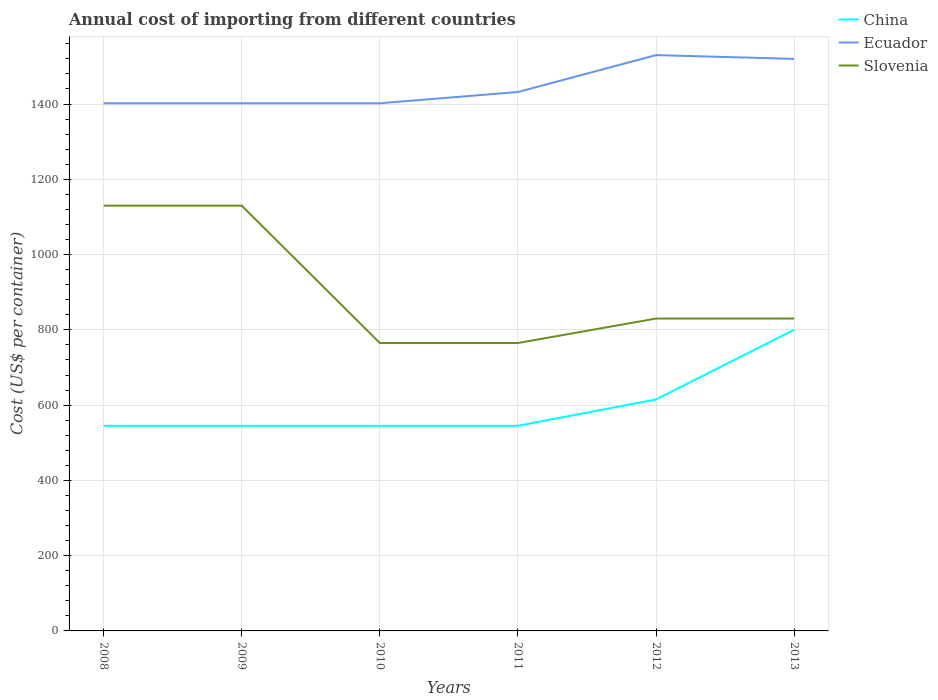How many different coloured lines are there?
Provide a short and direct response. 3. Across all years, what is the maximum total annual cost of importing in China?
Provide a succinct answer. 545. In which year was the total annual cost of importing in China maximum?
Keep it short and to the point. 2008. What is the difference between the highest and the second highest total annual cost of importing in Slovenia?
Ensure brevity in your answer.  365. What is the difference between the highest and the lowest total annual cost of importing in Slovenia?
Your answer should be very brief. 2. Is the total annual cost of importing in Ecuador strictly greater than the total annual cost of importing in China over the years?
Provide a succinct answer. No. How many years are there in the graph?
Offer a terse response. 6. Does the graph contain grids?
Make the answer very short. Yes. How many legend labels are there?
Make the answer very short. 3. What is the title of the graph?
Keep it short and to the point. Annual cost of importing from different countries. What is the label or title of the Y-axis?
Provide a short and direct response. Cost (US$ per container). What is the Cost (US$ per container) of China in 2008?
Your answer should be very brief. 545. What is the Cost (US$ per container) in Ecuador in 2008?
Ensure brevity in your answer.  1402. What is the Cost (US$ per container) of Slovenia in 2008?
Your answer should be very brief. 1130. What is the Cost (US$ per container) of China in 2009?
Ensure brevity in your answer.  545. What is the Cost (US$ per container) in Ecuador in 2009?
Your answer should be very brief. 1402. What is the Cost (US$ per container) of Slovenia in 2009?
Your answer should be very brief. 1130. What is the Cost (US$ per container) in China in 2010?
Ensure brevity in your answer.  545. What is the Cost (US$ per container) of Ecuador in 2010?
Provide a short and direct response. 1402. What is the Cost (US$ per container) of Slovenia in 2010?
Your answer should be very brief. 765. What is the Cost (US$ per container) in China in 2011?
Your answer should be compact. 545. What is the Cost (US$ per container) of Ecuador in 2011?
Ensure brevity in your answer.  1432. What is the Cost (US$ per container) in Slovenia in 2011?
Provide a short and direct response. 765. What is the Cost (US$ per container) of China in 2012?
Offer a very short reply. 615. What is the Cost (US$ per container) of Ecuador in 2012?
Keep it short and to the point. 1530. What is the Cost (US$ per container) in Slovenia in 2012?
Your response must be concise. 830. What is the Cost (US$ per container) of China in 2013?
Your answer should be compact. 800. What is the Cost (US$ per container) of Ecuador in 2013?
Your answer should be very brief. 1520. What is the Cost (US$ per container) of Slovenia in 2013?
Provide a short and direct response. 830. Across all years, what is the maximum Cost (US$ per container) in China?
Your answer should be very brief. 800. Across all years, what is the maximum Cost (US$ per container) in Ecuador?
Your answer should be compact. 1530. Across all years, what is the maximum Cost (US$ per container) of Slovenia?
Your answer should be very brief. 1130. Across all years, what is the minimum Cost (US$ per container) of China?
Offer a terse response. 545. Across all years, what is the minimum Cost (US$ per container) of Ecuador?
Your answer should be very brief. 1402. Across all years, what is the minimum Cost (US$ per container) of Slovenia?
Your answer should be very brief. 765. What is the total Cost (US$ per container) of China in the graph?
Your answer should be compact. 3595. What is the total Cost (US$ per container) of Ecuador in the graph?
Offer a terse response. 8688. What is the total Cost (US$ per container) of Slovenia in the graph?
Ensure brevity in your answer.  5450. What is the difference between the Cost (US$ per container) of China in 2008 and that in 2009?
Provide a succinct answer. 0. What is the difference between the Cost (US$ per container) of Ecuador in 2008 and that in 2009?
Your answer should be very brief. 0. What is the difference between the Cost (US$ per container) in Slovenia in 2008 and that in 2009?
Your answer should be very brief. 0. What is the difference between the Cost (US$ per container) in Slovenia in 2008 and that in 2010?
Offer a terse response. 365. What is the difference between the Cost (US$ per container) in Ecuador in 2008 and that in 2011?
Make the answer very short. -30. What is the difference between the Cost (US$ per container) of Slovenia in 2008 and that in 2011?
Ensure brevity in your answer.  365. What is the difference between the Cost (US$ per container) of China in 2008 and that in 2012?
Give a very brief answer. -70. What is the difference between the Cost (US$ per container) in Ecuador in 2008 and that in 2012?
Offer a terse response. -128. What is the difference between the Cost (US$ per container) in Slovenia in 2008 and that in 2012?
Keep it short and to the point. 300. What is the difference between the Cost (US$ per container) in China in 2008 and that in 2013?
Your response must be concise. -255. What is the difference between the Cost (US$ per container) in Ecuador in 2008 and that in 2013?
Offer a terse response. -118. What is the difference between the Cost (US$ per container) of Slovenia in 2008 and that in 2013?
Keep it short and to the point. 300. What is the difference between the Cost (US$ per container) of Ecuador in 2009 and that in 2010?
Ensure brevity in your answer.  0. What is the difference between the Cost (US$ per container) of Slovenia in 2009 and that in 2010?
Your answer should be compact. 365. What is the difference between the Cost (US$ per container) in Ecuador in 2009 and that in 2011?
Your answer should be very brief. -30. What is the difference between the Cost (US$ per container) of Slovenia in 2009 and that in 2011?
Offer a terse response. 365. What is the difference between the Cost (US$ per container) of China in 2009 and that in 2012?
Your response must be concise. -70. What is the difference between the Cost (US$ per container) of Ecuador in 2009 and that in 2012?
Provide a short and direct response. -128. What is the difference between the Cost (US$ per container) in Slovenia in 2009 and that in 2012?
Offer a terse response. 300. What is the difference between the Cost (US$ per container) of China in 2009 and that in 2013?
Your answer should be very brief. -255. What is the difference between the Cost (US$ per container) in Ecuador in 2009 and that in 2013?
Your answer should be compact. -118. What is the difference between the Cost (US$ per container) of Slovenia in 2009 and that in 2013?
Offer a terse response. 300. What is the difference between the Cost (US$ per container) in China in 2010 and that in 2011?
Provide a succinct answer. 0. What is the difference between the Cost (US$ per container) of Ecuador in 2010 and that in 2011?
Offer a terse response. -30. What is the difference between the Cost (US$ per container) of Slovenia in 2010 and that in 2011?
Your answer should be very brief. 0. What is the difference between the Cost (US$ per container) in China in 2010 and that in 2012?
Your answer should be compact. -70. What is the difference between the Cost (US$ per container) of Ecuador in 2010 and that in 2012?
Your response must be concise. -128. What is the difference between the Cost (US$ per container) of Slovenia in 2010 and that in 2012?
Your response must be concise. -65. What is the difference between the Cost (US$ per container) in China in 2010 and that in 2013?
Keep it short and to the point. -255. What is the difference between the Cost (US$ per container) in Ecuador in 2010 and that in 2013?
Ensure brevity in your answer.  -118. What is the difference between the Cost (US$ per container) in Slovenia in 2010 and that in 2013?
Provide a short and direct response. -65. What is the difference between the Cost (US$ per container) in China in 2011 and that in 2012?
Make the answer very short. -70. What is the difference between the Cost (US$ per container) of Ecuador in 2011 and that in 2012?
Offer a terse response. -98. What is the difference between the Cost (US$ per container) of Slovenia in 2011 and that in 2012?
Your response must be concise. -65. What is the difference between the Cost (US$ per container) of China in 2011 and that in 2013?
Provide a short and direct response. -255. What is the difference between the Cost (US$ per container) of Ecuador in 2011 and that in 2013?
Make the answer very short. -88. What is the difference between the Cost (US$ per container) in Slovenia in 2011 and that in 2013?
Make the answer very short. -65. What is the difference between the Cost (US$ per container) in China in 2012 and that in 2013?
Ensure brevity in your answer.  -185. What is the difference between the Cost (US$ per container) of Ecuador in 2012 and that in 2013?
Keep it short and to the point. 10. What is the difference between the Cost (US$ per container) of China in 2008 and the Cost (US$ per container) of Ecuador in 2009?
Provide a succinct answer. -857. What is the difference between the Cost (US$ per container) in China in 2008 and the Cost (US$ per container) in Slovenia in 2009?
Offer a very short reply. -585. What is the difference between the Cost (US$ per container) in Ecuador in 2008 and the Cost (US$ per container) in Slovenia in 2009?
Provide a short and direct response. 272. What is the difference between the Cost (US$ per container) in China in 2008 and the Cost (US$ per container) in Ecuador in 2010?
Provide a succinct answer. -857. What is the difference between the Cost (US$ per container) in China in 2008 and the Cost (US$ per container) in Slovenia in 2010?
Your answer should be very brief. -220. What is the difference between the Cost (US$ per container) of Ecuador in 2008 and the Cost (US$ per container) of Slovenia in 2010?
Your response must be concise. 637. What is the difference between the Cost (US$ per container) in China in 2008 and the Cost (US$ per container) in Ecuador in 2011?
Make the answer very short. -887. What is the difference between the Cost (US$ per container) in China in 2008 and the Cost (US$ per container) in Slovenia in 2011?
Provide a succinct answer. -220. What is the difference between the Cost (US$ per container) in Ecuador in 2008 and the Cost (US$ per container) in Slovenia in 2011?
Offer a very short reply. 637. What is the difference between the Cost (US$ per container) of China in 2008 and the Cost (US$ per container) of Ecuador in 2012?
Keep it short and to the point. -985. What is the difference between the Cost (US$ per container) of China in 2008 and the Cost (US$ per container) of Slovenia in 2012?
Make the answer very short. -285. What is the difference between the Cost (US$ per container) in Ecuador in 2008 and the Cost (US$ per container) in Slovenia in 2012?
Your answer should be very brief. 572. What is the difference between the Cost (US$ per container) in China in 2008 and the Cost (US$ per container) in Ecuador in 2013?
Provide a succinct answer. -975. What is the difference between the Cost (US$ per container) of China in 2008 and the Cost (US$ per container) of Slovenia in 2013?
Your response must be concise. -285. What is the difference between the Cost (US$ per container) in Ecuador in 2008 and the Cost (US$ per container) in Slovenia in 2013?
Provide a succinct answer. 572. What is the difference between the Cost (US$ per container) of China in 2009 and the Cost (US$ per container) of Ecuador in 2010?
Your response must be concise. -857. What is the difference between the Cost (US$ per container) of China in 2009 and the Cost (US$ per container) of Slovenia in 2010?
Ensure brevity in your answer.  -220. What is the difference between the Cost (US$ per container) of Ecuador in 2009 and the Cost (US$ per container) of Slovenia in 2010?
Offer a terse response. 637. What is the difference between the Cost (US$ per container) in China in 2009 and the Cost (US$ per container) in Ecuador in 2011?
Keep it short and to the point. -887. What is the difference between the Cost (US$ per container) of China in 2009 and the Cost (US$ per container) of Slovenia in 2011?
Ensure brevity in your answer.  -220. What is the difference between the Cost (US$ per container) in Ecuador in 2009 and the Cost (US$ per container) in Slovenia in 2011?
Your response must be concise. 637. What is the difference between the Cost (US$ per container) of China in 2009 and the Cost (US$ per container) of Ecuador in 2012?
Offer a very short reply. -985. What is the difference between the Cost (US$ per container) in China in 2009 and the Cost (US$ per container) in Slovenia in 2012?
Give a very brief answer. -285. What is the difference between the Cost (US$ per container) in Ecuador in 2009 and the Cost (US$ per container) in Slovenia in 2012?
Provide a succinct answer. 572. What is the difference between the Cost (US$ per container) in China in 2009 and the Cost (US$ per container) in Ecuador in 2013?
Your answer should be compact. -975. What is the difference between the Cost (US$ per container) of China in 2009 and the Cost (US$ per container) of Slovenia in 2013?
Keep it short and to the point. -285. What is the difference between the Cost (US$ per container) in Ecuador in 2009 and the Cost (US$ per container) in Slovenia in 2013?
Keep it short and to the point. 572. What is the difference between the Cost (US$ per container) in China in 2010 and the Cost (US$ per container) in Ecuador in 2011?
Your answer should be compact. -887. What is the difference between the Cost (US$ per container) in China in 2010 and the Cost (US$ per container) in Slovenia in 2011?
Offer a terse response. -220. What is the difference between the Cost (US$ per container) of Ecuador in 2010 and the Cost (US$ per container) of Slovenia in 2011?
Provide a short and direct response. 637. What is the difference between the Cost (US$ per container) of China in 2010 and the Cost (US$ per container) of Ecuador in 2012?
Provide a short and direct response. -985. What is the difference between the Cost (US$ per container) of China in 2010 and the Cost (US$ per container) of Slovenia in 2012?
Ensure brevity in your answer.  -285. What is the difference between the Cost (US$ per container) in Ecuador in 2010 and the Cost (US$ per container) in Slovenia in 2012?
Offer a very short reply. 572. What is the difference between the Cost (US$ per container) of China in 2010 and the Cost (US$ per container) of Ecuador in 2013?
Provide a succinct answer. -975. What is the difference between the Cost (US$ per container) in China in 2010 and the Cost (US$ per container) in Slovenia in 2013?
Give a very brief answer. -285. What is the difference between the Cost (US$ per container) in Ecuador in 2010 and the Cost (US$ per container) in Slovenia in 2013?
Offer a very short reply. 572. What is the difference between the Cost (US$ per container) in China in 2011 and the Cost (US$ per container) in Ecuador in 2012?
Make the answer very short. -985. What is the difference between the Cost (US$ per container) in China in 2011 and the Cost (US$ per container) in Slovenia in 2012?
Keep it short and to the point. -285. What is the difference between the Cost (US$ per container) of Ecuador in 2011 and the Cost (US$ per container) of Slovenia in 2012?
Provide a short and direct response. 602. What is the difference between the Cost (US$ per container) of China in 2011 and the Cost (US$ per container) of Ecuador in 2013?
Your answer should be compact. -975. What is the difference between the Cost (US$ per container) in China in 2011 and the Cost (US$ per container) in Slovenia in 2013?
Your answer should be compact. -285. What is the difference between the Cost (US$ per container) of Ecuador in 2011 and the Cost (US$ per container) of Slovenia in 2013?
Give a very brief answer. 602. What is the difference between the Cost (US$ per container) in China in 2012 and the Cost (US$ per container) in Ecuador in 2013?
Offer a very short reply. -905. What is the difference between the Cost (US$ per container) of China in 2012 and the Cost (US$ per container) of Slovenia in 2013?
Provide a succinct answer. -215. What is the difference between the Cost (US$ per container) of Ecuador in 2012 and the Cost (US$ per container) of Slovenia in 2013?
Ensure brevity in your answer.  700. What is the average Cost (US$ per container) in China per year?
Provide a short and direct response. 599.17. What is the average Cost (US$ per container) in Ecuador per year?
Offer a very short reply. 1448. What is the average Cost (US$ per container) in Slovenia per year?
Your response must be concise. 908.33. In the year 2008, what is the difference between the Cost (US$ per container) in China and Cost (US$ per container) in Ecuador?
Your response must be concise. -857. In the year 2008, what is the difference between the Cost (US$ per container) of China and Cost (US$ per container) of Slovenia?
Your response must be concise. -585. In the year 2008, what is the difference between the Cost (US$ per container) in Ecuador and Cost (US$ per container) in Slovenia?
Your answer should be compact. 272. In the year 2009, what is the difference between the Cost (US$ per container) of China and Cost (US$ per container) of Ecuador?
Offer a terse response. -857. In the year 2009, what is the difference between the Cost (US$ per container) in China and Cost (US$ per container) in Slovenia?
Give a very brief answer. -585. In the year 2009, what is the difference between the Cost (US$ per container) in Ecuador and Cost (US$ per container) in Slovenia?
Your answer should be very brief. 272. In the year 2010, what is the difference between the Cost (US$ per container) in China and Cost (US$ per container) in Ecuador?
Ensure brevity in your answer.  -857. In the year 2010, what is the difference between the Cost (US$ per container) in China and Cost (US$ per container) in Slovenia?
Your response must be concise. -220. In the year 2010, what is the difference between the Cost (US$ per container) of Ecuador and Cost (US$ per container) of Slovenia?
Give a very brief answer. 637. In the year 2011, what is the difference between the Cost (US$ per container) in China and Cost (US$ per container) in Ecuador?
Give a very brief answer. -887. In the year 2011, what is the difference between the Cost (US$ per container) of China and Cost (US$ per container) of Slovenia?
Offer a terse response. -220. In the year 2011, what is the difference between the Cost (US$ per container) in Ecuador and Cost (US$ per container) in Slovenia?
Offer a terse response. 667. In the year 2012, what is the difference between the Cost (US$ per container) in China and Cost (US$ per container) in Ecuador?
Ensure brevity in your answer.  -915. In the year 2012, what is the difference between the Cost (US$ per container) in China and Cost (US$ per container) in Slovenia?
Your answer should be compact. -215. In the year 2012, what is the difference between the Cost (US$ per container) in Ecuador and Cost (US$ per container) in Slovenia?
Your answer should be compact. 700. In the year 2013, what is the difference between the Cost (US$ per container) of China and Cost (US$ per container) of Ecuador?
Your answer should be compact. -720. In the year 2013, what is the difference between the Cost (US$ per container) in China and Cost (US$ per container) in Slovenia?
Offer a very short reply. -30. In the year 2013, what is the difference between the Cost (US$ per container) of Ecuador and Cost (US$ per container) of Slovenia?
Offer a terse response. 690. What is the ratio of the Cost (US$ per container) in Slovenia in 2008 to that in 2009?
Provide a short and direct response. 1. What is the ratio of the Cost (US$ per container) of Ecuador in 2008 to that in 2010?
Your answer should be compact. 1. What is the ratio of the Cost (US$ per container) of Slovenia in 2008 to that in 2010?
Provide a short and direct response. 1.48. What is the ratio of the Cost (US$ per container) in Ecuador in 2008 to that in 2011?
Your response must be concise. 0.98. What is the ratio of the Cost (US$ per container) in Slovenia in 2008 to that in 2011?
Ensure brevity in your answer.  1.48. What is the ratio of the Cost (US$ per container) in China in 2008 to that in 2012?
Your answer should be compact. 0.89. What is the ratio of the Cost (US$ per container) of Ecuador in 2008 to that in 2012?
Your answer should be compact. 0.92. What is the ratio of the Cost (US$ per container) in Slovenia in 2008 to that in 2012?
Make the answer very short. 1.36. What is the ratio of the Cost (US$ per container) of China in 2008 to that in 2013?
Your answer should be compact. 0.68. What is the ratio of the Cost (US$ per container) in Ecuador in 2008 to that in 2013?
Make the answer very short. 0.92. What is the ratio of the Cost (US$ per container) of Slovenia in 2008 to that in 2013?
Keep it short and to the point. 1.36. What is the ratio of the Cost (US$ per container) in China in 2009 to that in 2010?
Offer a terse response. 1. What is the ratio of the Cost (US$ per container) in Slovenia in 2009 to that in 2010?
Provide a succinct answer. 1.48. What is the ratio of the Cost (US$ per container) of Ecuador in 2009 to that in 2011?
Offer a very short reply. 0.98. What is the ratio of the Cost (US$ per container) in Slovenia in 2009 to that in 2011?
Your answer should be very brief. 1.48. What is the ratio of the Cost (US$ per container) in China in 2009 to that in 2012?
Give a very brief answer. 0.89. What is the ratio of the Cost (US$ per container) in Ecuador in 2009 to that in 2012?
Offer a very short reply. 0.92. What is the ratio of the Cost (US$ per container) in Slovenia in 2009 to that in 2012?
Your answer should be very brief. 1.36. What is the ratio of the Cost (US$ per container) of China in 2009 to that in 2013?
Keep it short and to the point. 0.68. What is the ratio of the Cost (US$ per container) in Ecuador in 2009 to that in 2013?
Provide a short and direct response. 0.92. What is the ratio of the Cost (US$ per container) of Slovenia in 2009 to that in 2013?
Your answer should be very brief. 1.36. What is the ratio of the Cost (US$ per container) in China in 2010 to that in 2011?
Your answer should be very brief. 1. What is the ratio of the Cost (US$ per container) in Ecuador in 2010 to that in 2011?
Offer a terse response. 0.98. What is the ratio of the Cost (US$ per container) of Slovenia in 2010 to that in 2011?
Offer a very short reply. 1. What is the ratio of the Cost (US$ per container) in China in 2010 to that in 2012?
Give a very brief answer. 0.89. What is the ratio of the Cost (US$ per container) in Ecuador in 2010 to that in 2012?
Offer a terse response. 0.92. What is the ratio of the Cost (US$ per container) in Slovenia in 2010 to that in 2012?
Keep it short and to the point. 0.92. What is the ratio of the Cost (US$ per container) in China in 2010 to that in 2013?
Keep it short and to the point. 0.68. What is the ratio of the Cost (US$ per container) in Ecuador in 2010 to that in 2013?
Ensure brevity in your answer.  0.92. What is the ratio of the Cost (US$ per container) of Slovenia in 2010 to that in 2013?
Your answer should be very brief. 0.92. What is the ratio of the Cost (US$ per container) of China in 2011 to that in 2012?
Give a very brief answer. 0.89. What is the ratio of the Cost (US$ per container) of Ecuador in 2011 to that in 2012?
Make the answer very short. 0.94. What is the ratio of the Cost (US$ per container) in Slovenia in 2011 to that in 2012?
Give a very brief answer. 0.92. What is the ratio of the Cost (US$ per container) of China in 2011 to that in 2013?
Provide a succinct answer. 0.68. What is the ratio of the Cost (US$ per container) of Ecuador in 2011 to that in 2013?
Make the answer very short. 0.94. What is the ratio of the Cost (US$ per container) in Slovenia in 2011 to that in 2013?
Your answer should be compact. 0.92. What is the ratio of the Cost (US$ per container) in China in 2012 to that in 2013?
Offer a terse response. 0.77. What is the ratio of the Cost (US$ per container) in Ecuador in 2012 to that in 2013?
Ensure brevity in your answer.  1.01. What is the difference between the highest and the second highest Cost (US$ per container) in China?
Your answer should be very brief. 185. What is the difference between the highest and the second highest Cost (US$ per container) in Slovenia?
Provide a short and direct response. 0. What is the difference between the highest and the lowest Cost (US$ per container) in China?
Ensure brevity in your answer.  255. What is the difference between the highest and the lowest Cost (US$ per container) of Ecuador?
Give a very brief answer. 128. What is the difference between the highest and the lowest Cost (US$ per container) of Slovenia?
Your answer should be compact. 365. 